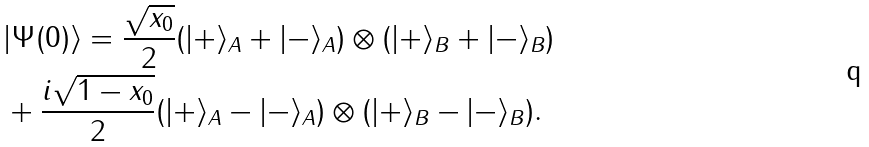Convert formula to latex. <formula><loc_0><loc_0><loc_500><loc_500>& | \Psi ( 0 ) \rangle = \frac { \sqrt { x _ { 0 } } } { 2 } ( | + \rangle _ { A } + | - \rangle _ { A } ) \otimes ( | + \rangle _ { B } + | - \rangle _ { B } ) \\ & + \frac { i \sqrt { 1 - x _ { 0 } } } { 2 } ( | + \rangle _ { A } - | - \rangle _ { A } ) \otimes ( | + \rangle _ { B } - | - \rangle _ { B } ) .</formula> 